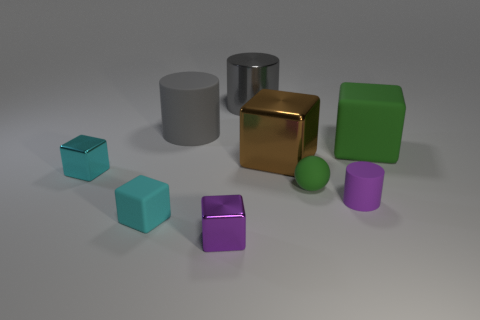Which objects in the image are reflecting light the most? The golden cube stands out with its highly reflective surface catching and bending the light, indicating a possible polished metal material. The silver cylinder nearby also has a noticeable reflection, consistent with a metal finish, though less pronounced than the cube's. 